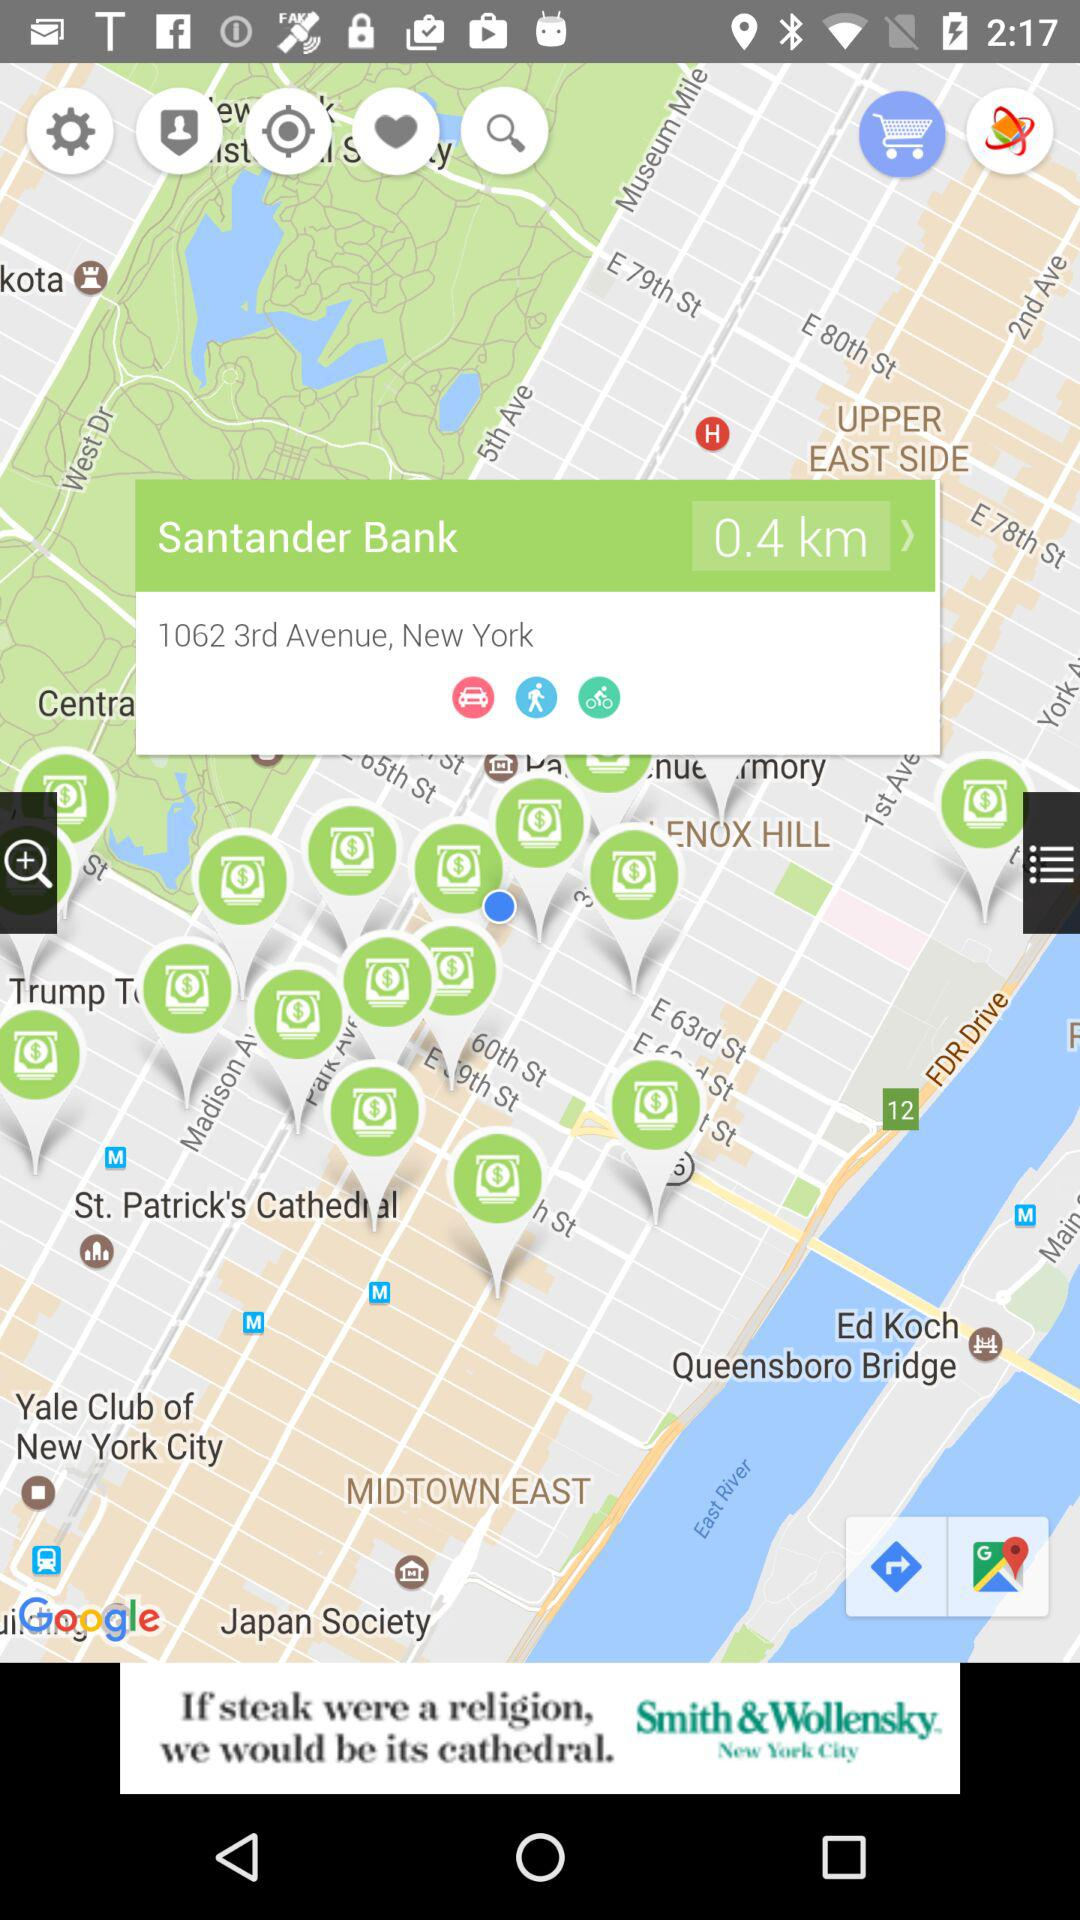What is the given address? The given address is 1062 3rd Avenue, New York. 